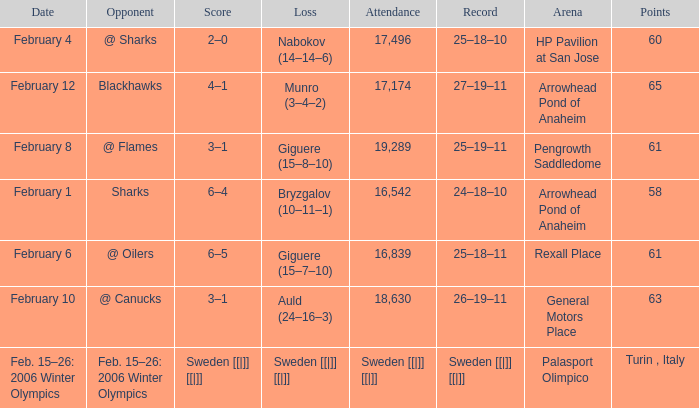What is the record when the score was 2–0? 25–18–10. 